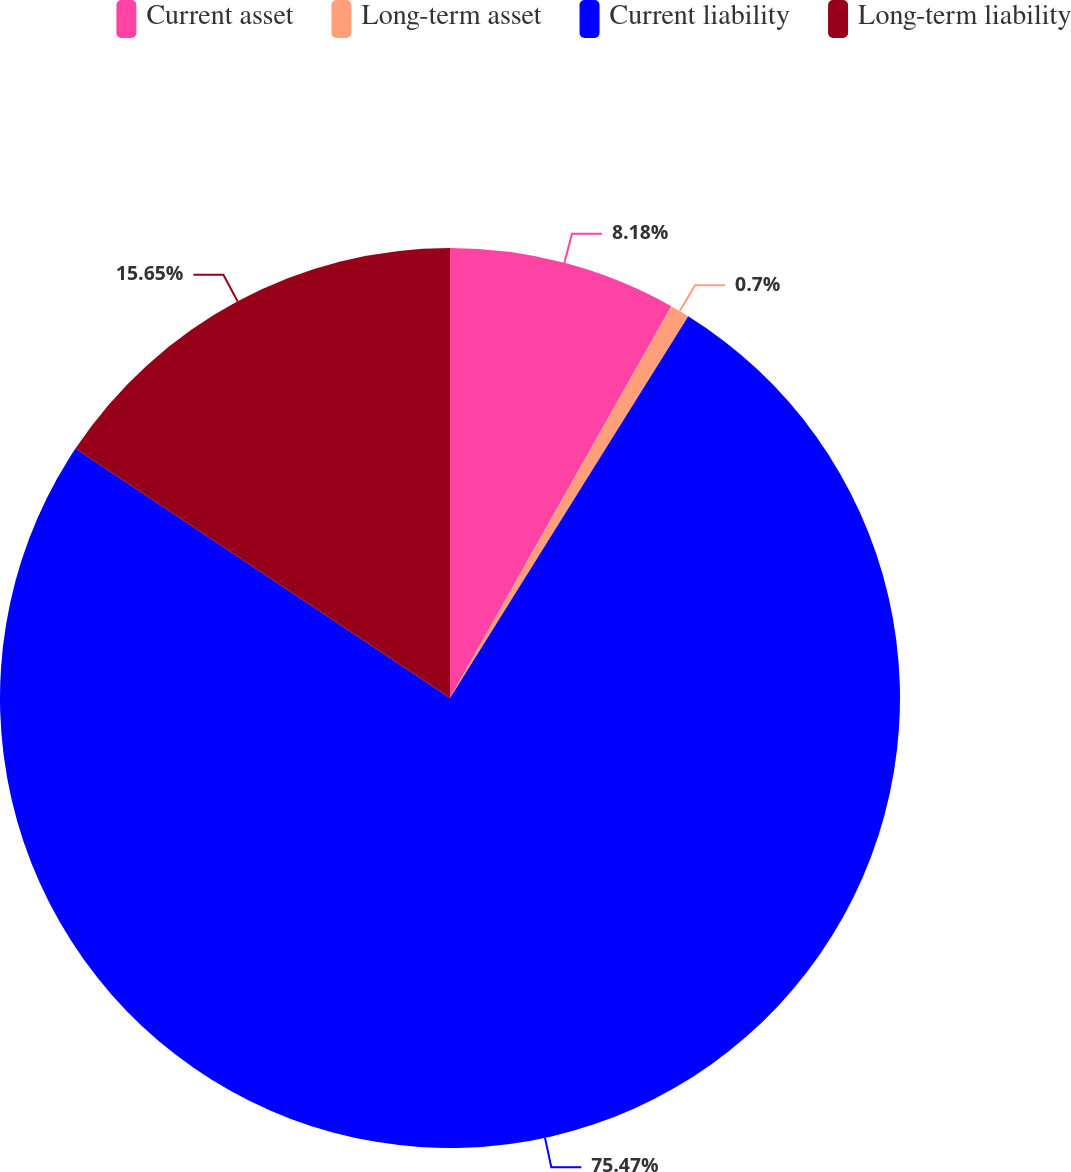Convert chart to OTSL. <chart><loc_0><loc_0><loc_500><loc_500><pie_chart><fcel>Current asset<fcel>Long-term asset<fcel>Current liability<fcel>Long-term liability<nl><fcel>8.18%<fcel>0.7%<fcel>75.47%<fcel>15.65%<nl></chart> 